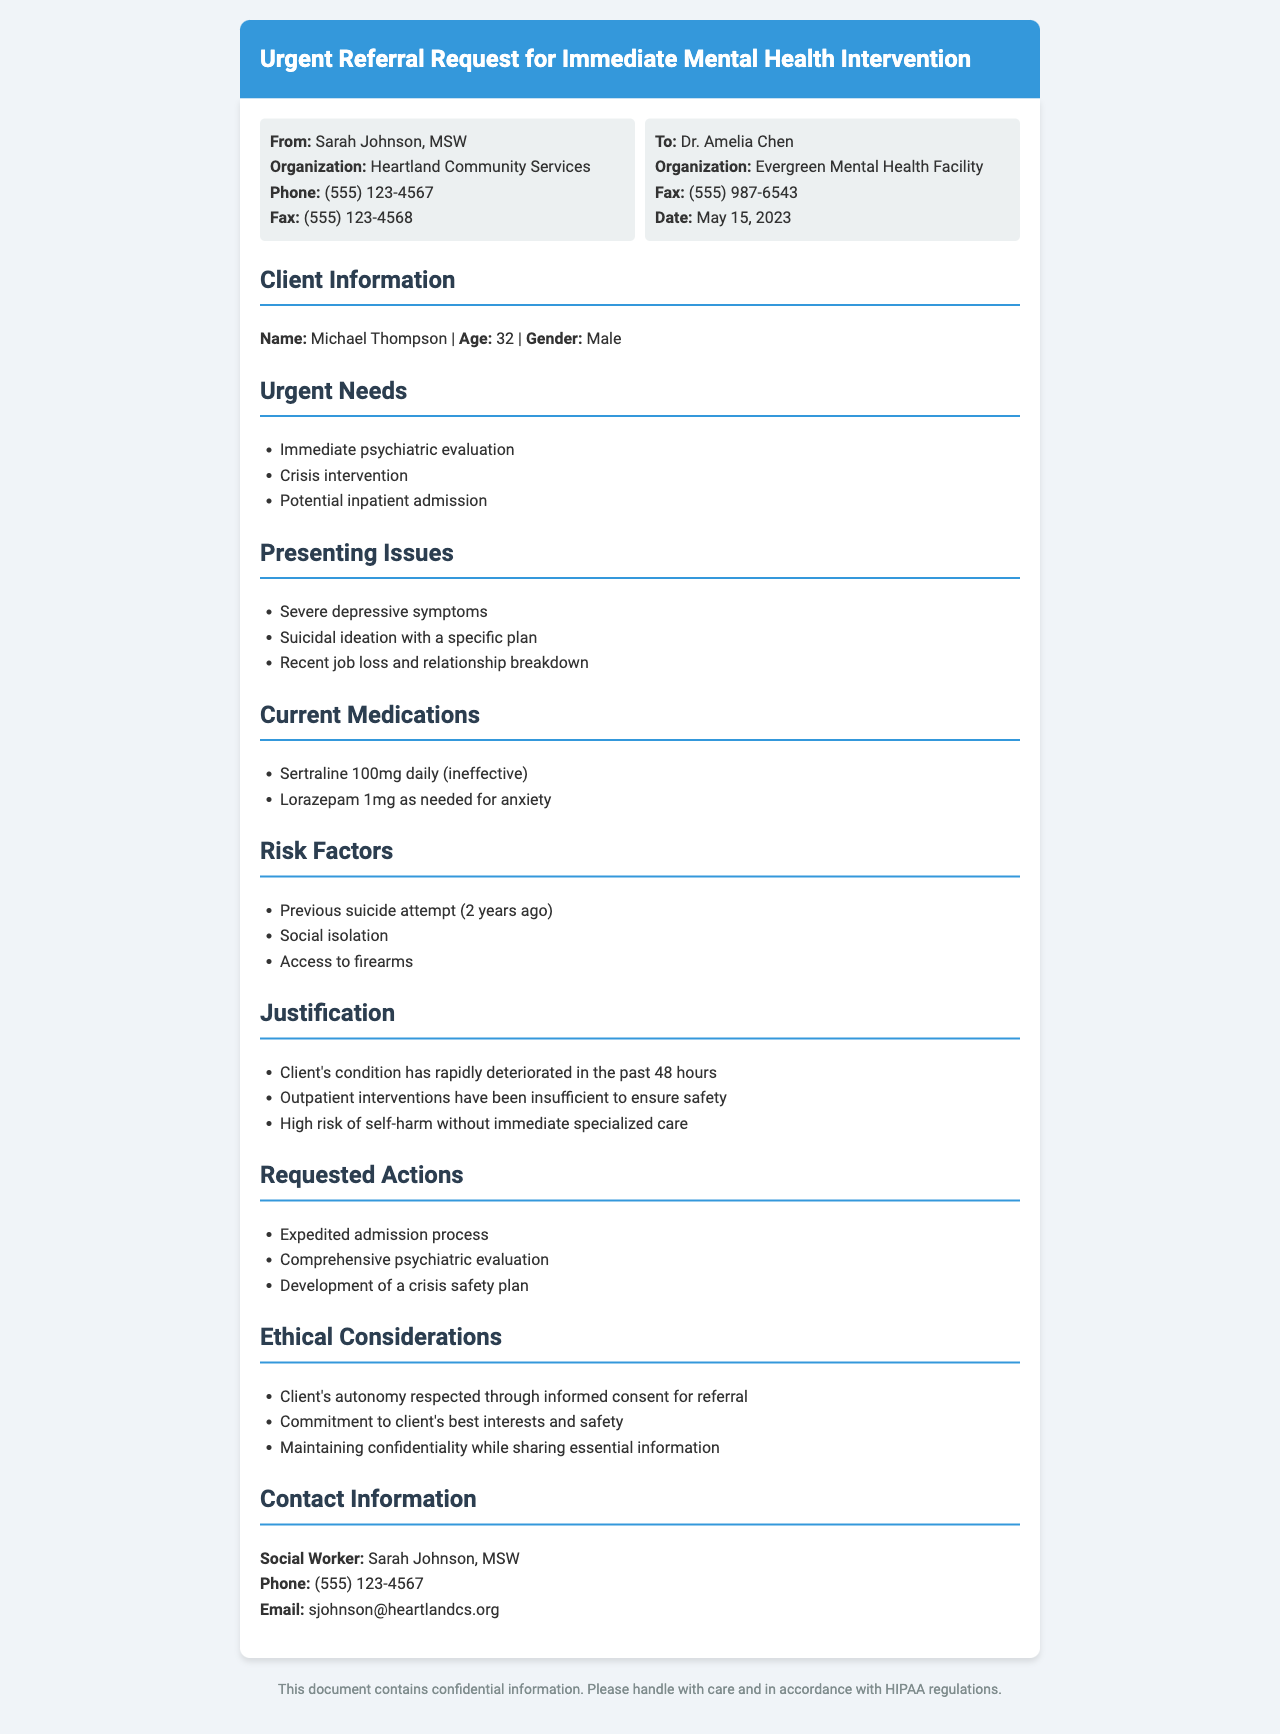What is the name of the client? The name of the client is explicitly mentioned in the document as Michael Thompson.
Answer: Michael Thompson What is the age of the client? The document states the age of the client next to their name.
Answer: 32 What are the immediate needs listed? The document outlines three immediate needs under the "Urgent Needs" section.
Answer: Immediate psychiatric evaluation, crisis intervention, potential inpatient admission What specific psychiatric medication is mentioned as ineffective? The document indicates that Sertraline 100mg daily is ineffective for the client.
Answer: Sertraline 100mg daily What risk factor is related to the client’s past behavior? The document details a previous suicide attempt as a significant risk factor for the client.
Answer: Previous suicide attempt What has caused the client's condition to deteriorate? The "Justification" section explains the rapid deterioration of the client's condition in the past 48 hours.
Answer: Rapid deterioration in the past 48 hours What is the requested action for the admission process? The document mentions that an expedited admission process is requested.
Answer: Expedited admission process How is the client's autonomy addressed? The ethical considerations section notes that the client's autonomy is respected through informed consent for referral.
Answer: Informed consent for referral 